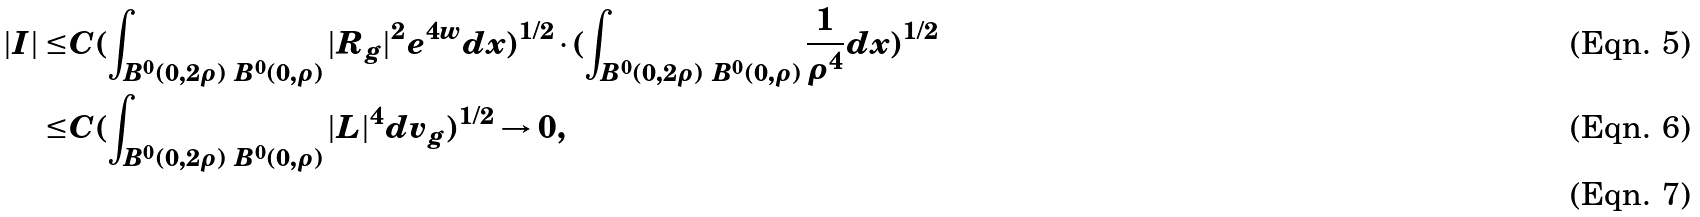<formula> <loc_0><loc_0><loc_500><loc_500>| I | \leq & C ( \int _ { B ^ { 0 } ( 0 , 2 \rho ) \ B ^ { 0 } ( 0 , \rho ) } | R _ { g } | ^ { 2 } e ^ { 4 w } d x ) ^ { 1 / 2 } \cdot ( \int _ { B ^ { 0 } ( 0 , 2 \rho ) \ B ^ { 0 } ( 0 , \rho ) } \frac { 1 } { \rho ^ { 4 } } d x ) ^ { 1 / 2 } \\ \leq & C ( \int _ { B ^ { 0 } ( 0 , 2 \rho ) \ B ^ { 0 } ( 0 , \rho ) } | L | ^ { 4 } d v _ { g } ) ^ { 1 / 2 } \rightarrow 0 , \\</formula> 